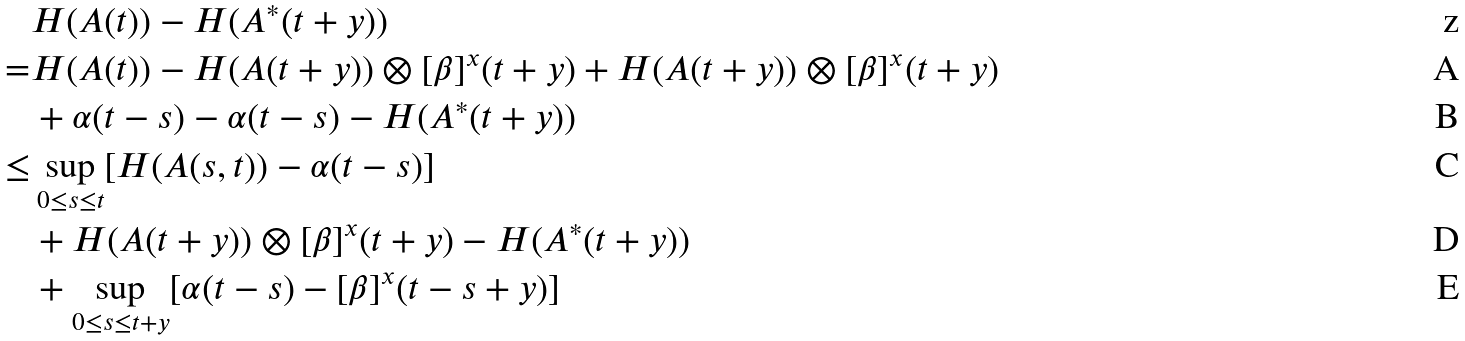Convert formula to latex. <formula><loc_0><loc_0><loc_500><loc_500>& H ( A ( t ) ) - H ( A ^ { * } ( t + y ) ) \\ = & H ( A ( t ) ) - H ( A ( t + y ) ) \otimes [ \beta ] ^ { x } ( t + y ) + H ( A ( t + y ) ) \otimes [ \beta ] ^ { x } ( t + y ) \\ & + \alpha ( t - s ) - \alpha ( t - s ) - H ( A ^ { * } ( t + y ) ) \\ \leq & \sup _ { 0 \leq s \leq t } [ H ( A ( s , t ) ) - \alpha ( t - s ) ] \\ & + H ( A ( t + y ) ) \otimes [ \beta ] ^ { x } ( t + y ) - H ( A ^ { * } ( t + y ) ) \\ & + \sup _ { 0 \leq s \leq t + y } [ \alpha ( t - s ) - [ \beta ] ^ { x } ( t - s + y ) ]</formula> 